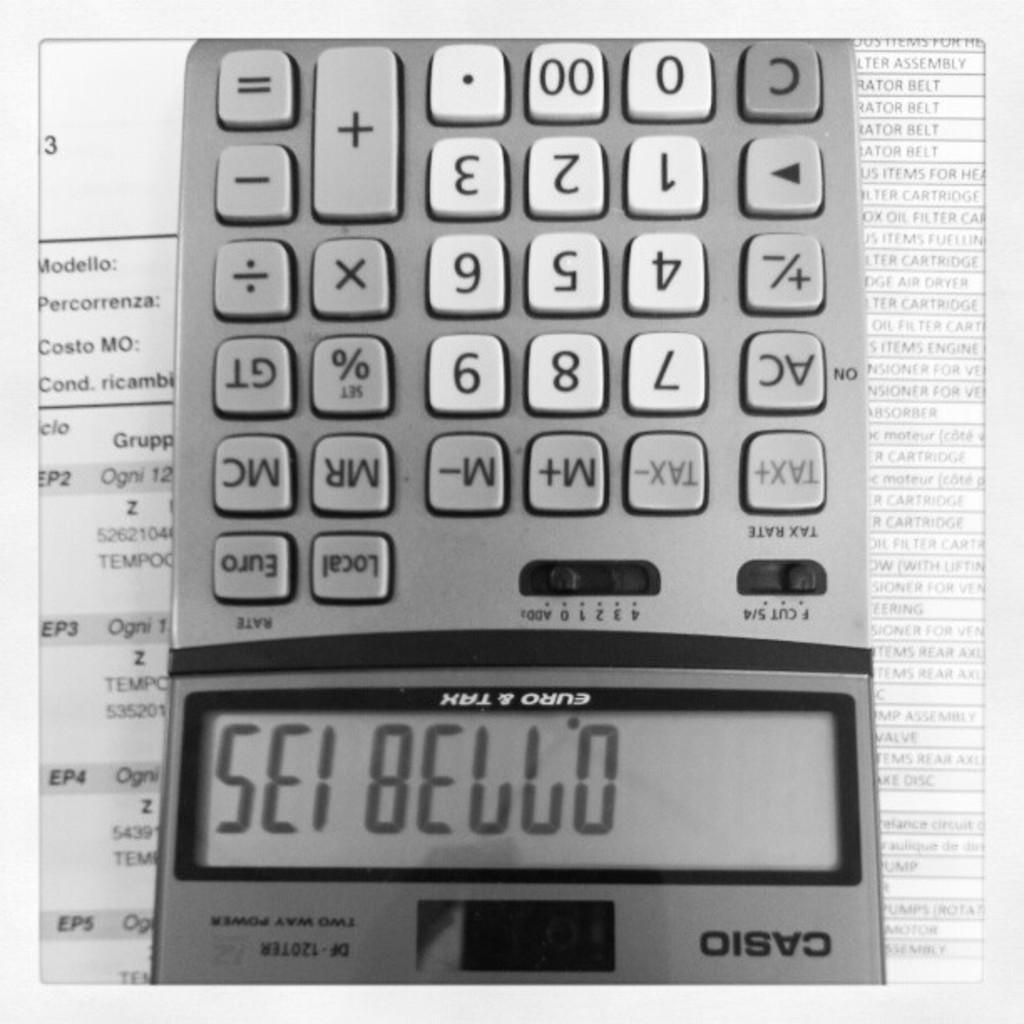<image>
Present a compact description of the photo's key features. Sei Bello is written on a Casio calculator 